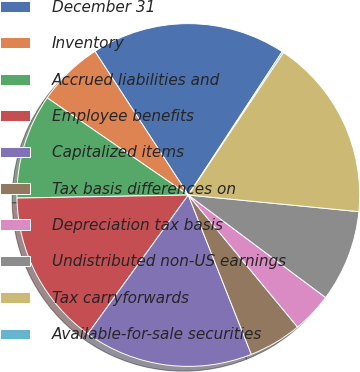Convert chart. <chart><loc_0><loc_0><loc_500><loc_500><pie_chart><fcel>December 31<fcel>Inventory<fcel>Accrued liabilities and<fcel>Employee benefits<fcel>Capitalized items<fcel>Tax basis differences on<fcel>Depreciation tax basis<fcel>Undistributed non-US earnings<fcel>Tax carryforwards<fcel>Available-for-sale securities<nl><fcel>18.4%<fcel>6.23%<fcel>9.88%<fcel>14.75%<fcel>15.96%<fcel>5.01%<fcel>3.79%<fcel>8.66%<fcel>17.18%<fcel>0.14%<nl></chart> 